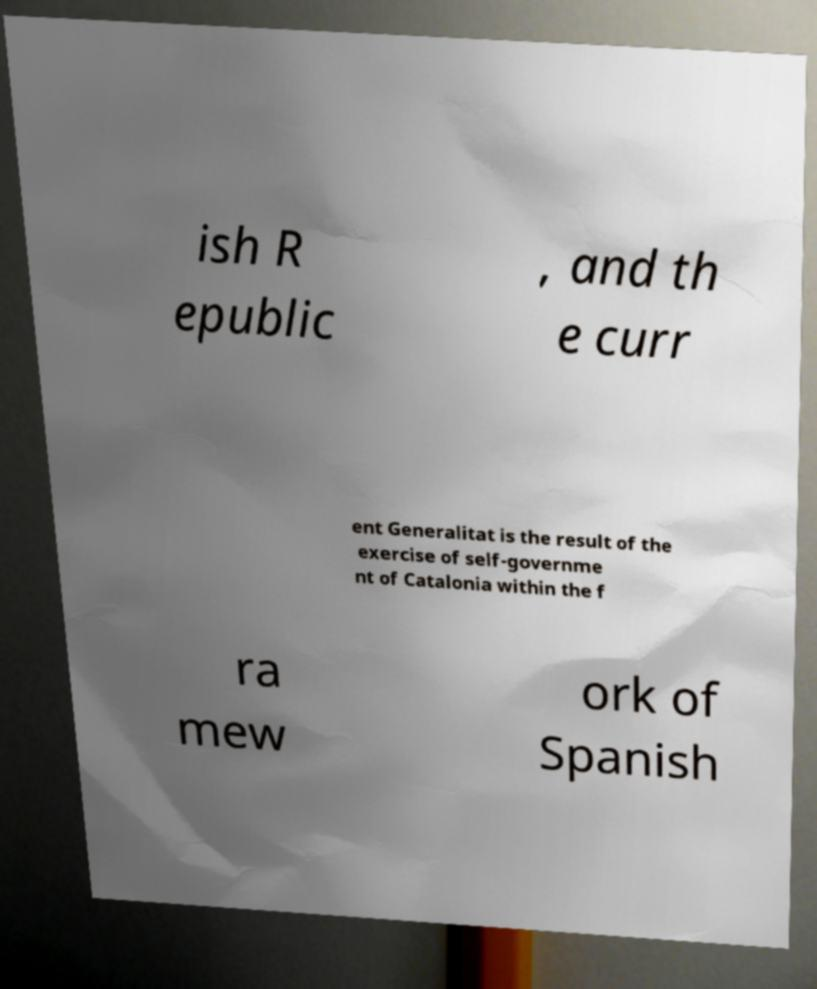There's text embedded in this image that I need extracted. Can you transcribe it verbatim? ish R epublic , and th e curr ent Generalitat is the result of the exercise of self-governme nt of Catalonia within the f ra mew ork of Spanish 